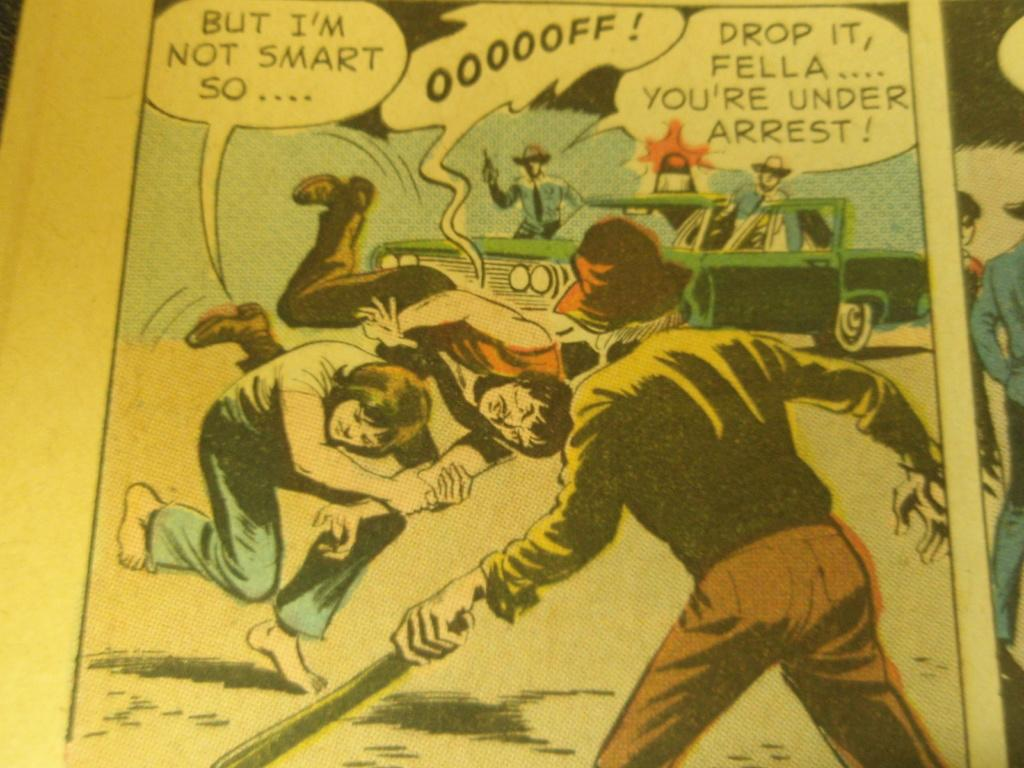<image>
Write a terse but informative summary of the picture. A scene from a comin book script wwith one character saying "But I'm not smart so ...." 